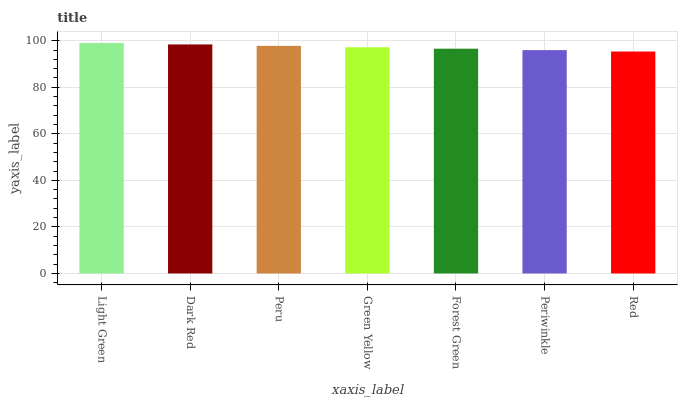Is Red the minimum?
Answer yes or no. Yes. Is Light Green the maximum?
Answer yes or no. Yes. Is Dark Red the minimum?
Answer yes or no. No. Is Dark Red the maximum?
Answer yes or no. No. Is Light Green greater than Dark Red?
Answer yes or no. Yes. Is Dark Red less than Light Green?
Answer yes or no. Yes. Is Dark Red greater than Light Green?
Answer yes or no. No. Is Light Green less than Dark Red?
Answer yes or no. No. Is Green Yellow the high median?
Answer yes or no. Yes. Is Green Yellow the low median?
Answer yes or no. Yes. Is Periwinkle the high median?
Answer yes or no. No. Is Periwinkle the low median?
Answer yes or no. No. 